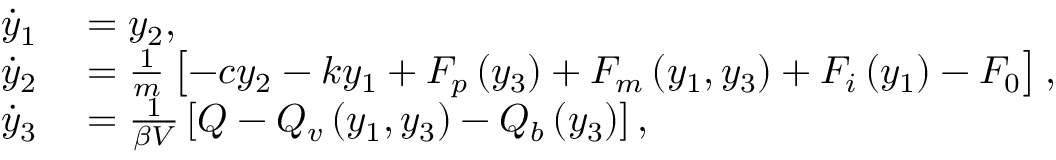<formula> <loc_0><loc_0><loc_500><loc_500>\begin{array} { r l } { \dot { y } _ { 1 } } & = y _ { 2 } , } \\ { \dot { y } _ { 2 } } & = \frac { 1 } { m } \left [ - c y _ { 2 } - k y _ { 1 } + F _ { p } \left ( y _ { 3 } \right ) + F _ { m } \left ( y _ { 1 } , y _ { 3 } \right ) + F _ { i } \left ( y _ { 1 } \right ) - F _ { 0 } \right ] , } \\ { \dot { y } _ { 3 } } & = \frac { 1 } { \beta V } \left [ Q - Q _ { v } \left ( y _ { 1 } , y _ { 3 } \right ) - Q _ { b } \left ( y _ { 3 } \right ) \right ] , } \end{array}</formula> 